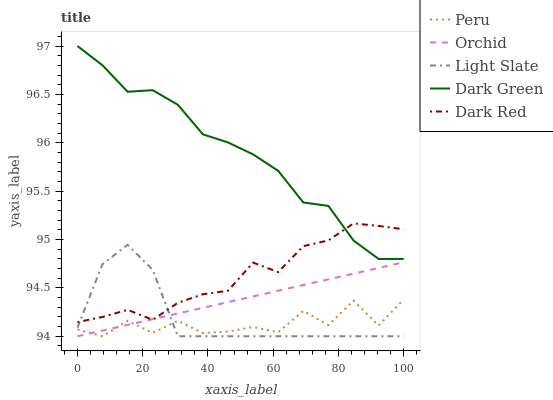Does Peru have the minimum area under the curve?
Answer yes or no. Yes. Does Dark Green have the maximum area under the curve?
Answer yes or no. Yes. Does Dark Red have the minimum area under the curve?
Answer yes or no. No. Does Dark Red have the maximum area under the curve?
Answer yes or no. No. Is Orchid the smoothest?
Answer yes or no. Yes. Is Peru the roughest?
Answer yes or no. Yes. Is Dark Red the smoothest?
Answer yes or no. No. Is Dark Red the roughest?
Answer yes or no. No. Does Light Slate have the lowest value?
Answer yes or no. Yes. Does Dark Red have the lowest value?
Answer yes or no. No. Does Dark Green have the highest value?
Answer yes or no. Yes. Does Dark Red have the highest value?
Answer yes or no. No. Is Peru less than Dark Red?
Answer yes or no. Yes. Is Dark Red greater than Peru?
Answer yes or no. Yes. Does Orchid intersect Light Slate?
Answer yes or no. Yes. Is Orchid less than Light Slate?
Answer yes or no. No. Is Orchid greater than Light Slate?
Answer yes or no. No. Does Peru intersect Dark Red?
Answer yes or no. No. 